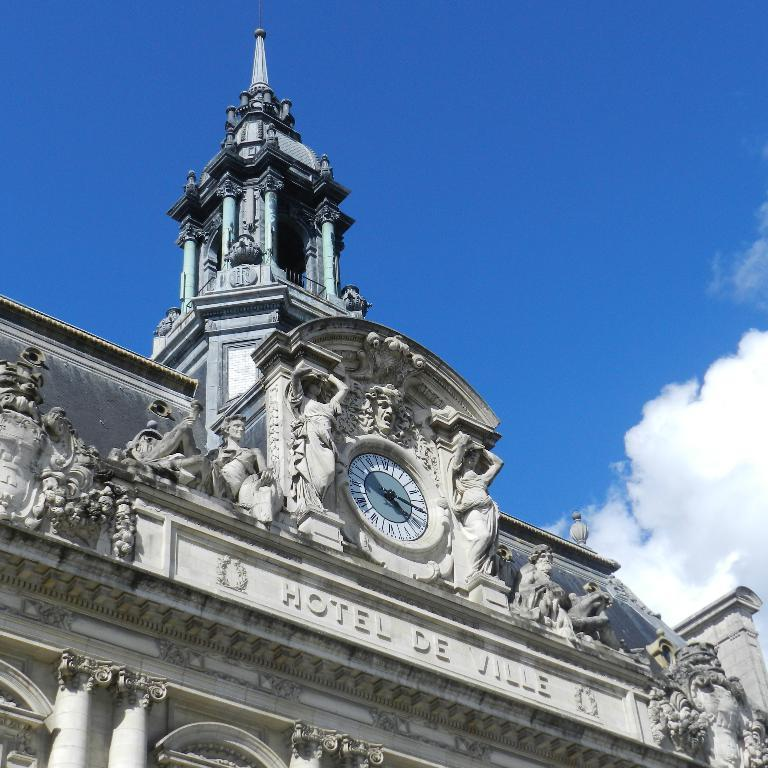Provide a one-sentence caption for the provided image. Hotel De Ville has a large steeple and clock above its name. 